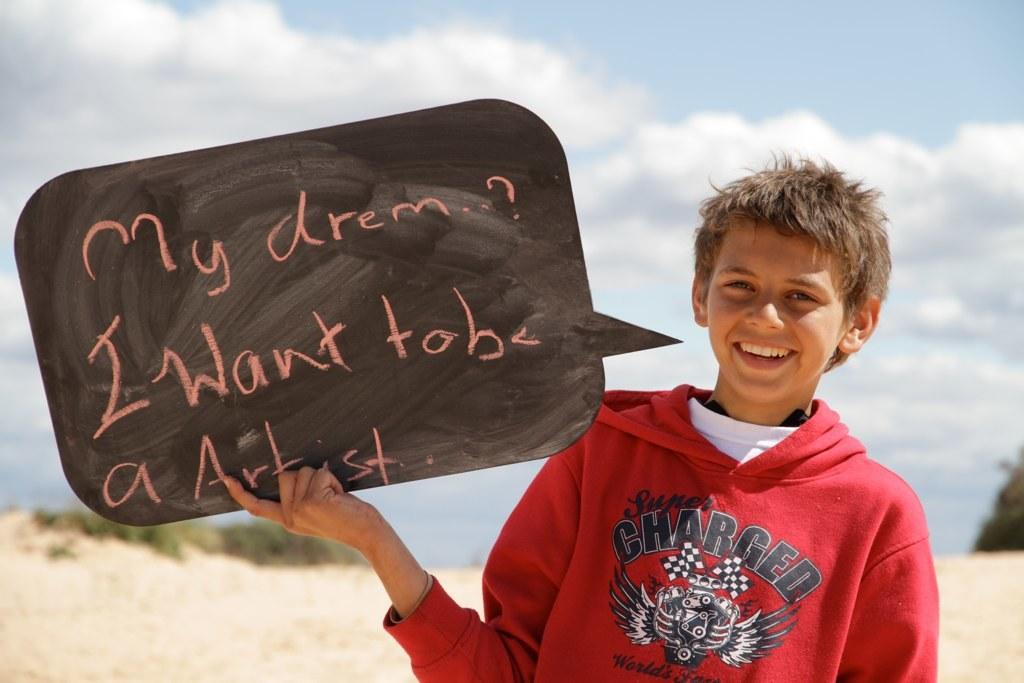Who is in the image? There is a boy in the image. What is the boy doing? The boy is laughing. What is the boy holding in the image? The boy is holding an object. Can you describe the object? There is text on the object. How is the background of the boy depicted? The background of the boy is blurred. What type of root can be seen growing from the boy's head in the image? There is no root growing from the boy's head in the image. 